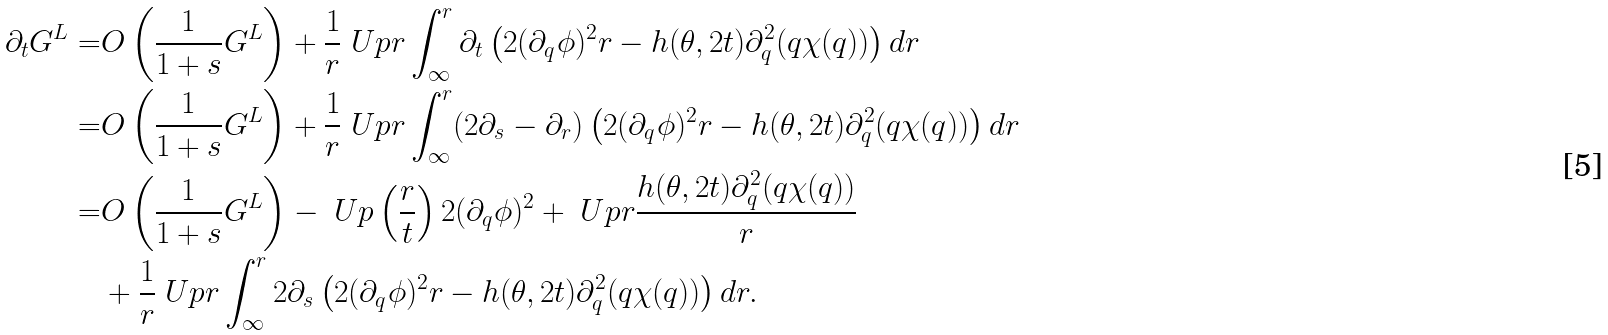Convert formula to latex. <formula><loc_0><loc_0><loc_500><loc_500>\partial _ { t } G ^ { L } = & O \left ( \frac { 1 } { 1 + s } G ^ { L } \right ) + \frac { 1 } { r } \ U p r \int _ { \infty } ^ { r } \partial _ { t } \left ( 2 ( \partial _ { q } \phi ) ^ { 2 } r - h ( \theta , 2 t ) \partial _ { q } ^ { 2 } ( q \chi ( q ) ) \right ) d r \\ = & O \left ( \frac { 1 } { 1 + s } G ^ { L } \right ) + \frac { 1 } { r } \ U p r \int _ { \infty } ^ { r } ( 2 \partial _ { s } - \partial _ { r } ) \left ( 2 ( \partial _ { q } \phi ) ^ { 2 } r - h ( \theta , 2 t ) \partial _ { q } ^ { 2 } ( q \chi ( q ) ) \right ) d r \\ = & O \left ( \frac { 1 } { 1 + s } G ^ { L } \right ) - \ U p \left ( \frac { r } { t } \right ) 2 ( \partial _ { q } \phi ) ^ { 2 } + \ U p r \frac { h ( \theta , 2 t ) \partial _ { q } ^ { 2 } ( q \chi ( q ) ) } { r } \\ & + \frac { 1 } { r } \ U p r \int _ { \infty } ^ { r } 2 \partial _ { s } \left ( 2 ( \partial _ { q } \phi ) ^ { 2 } r - h ( \theta , 2 t ) \partial _ { q } ^ { 2 } ( q \chi ( q ) ) \right ) d r .</formula> 